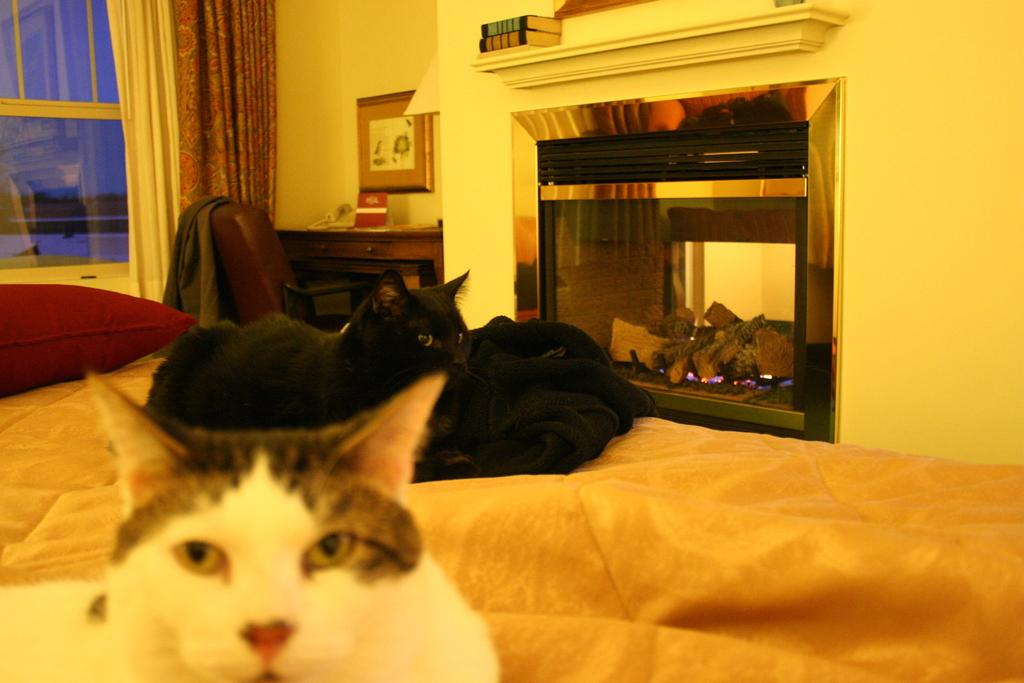How many cats are sitting on the bed in the image? There are two cats sitting on the bed in the image. What is on the bed besides the cats? There is a pillow on the bed. What can be seen in the background of the image? There is a desk curtain in the image. What type of objects can be seen in the image? There are books and other objects in the image. What piece of furniture is present in the image? There is a chair in the image. What type of clothing is visible in the image? There is a jacket in the image. What type of structure is the cats using to sail in the image? There is no structure or sail present in the image; it features two cats sitting on a bed. 